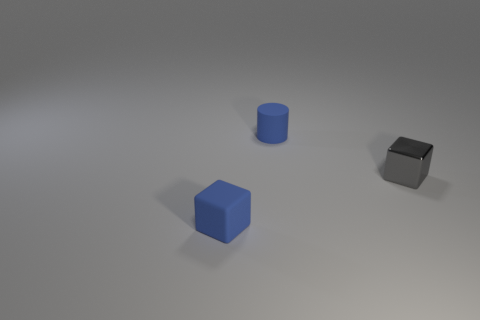There is a tiny thing that is the same material as the small cylinder; what is its color?
Ensure brevity in your answer.  Blue. How many rubber cylinders have the same size as the shiny thing?
Your answer should be compact. 1. What number of other objects are the same color as the metallic thing?
Your answer should be very brief. 0. Does the gray shiny object that is right of the blue block have the same shape as the tiny thing in front of the gray metallic object?
Your response must be concise. Yes. What is the shape of the gray metallic object that is the same size as the blue matte cylinder?
Give a very brief answer. Cube. Are there the same number of metallic things that are behind the blue rubber block and metal things that are behind the metallic thing?
Offer a very short reply. No. Do the object that is behind the tiny gray metal thing and the tiny blue block have the same material?
Provide a succinct answer. Yes. There is a blue cube that is the same size as the cylinder; what is it made of?
Offer a terse response. Rubber. How many other things are there of the same material as the tiny gray block?
Your response must be concise. 0. Are there fewer blue cylinders on the left side of the matte cylinder than blue matte things that are behind the blue block?
Provide a short and direct response. Yes. 